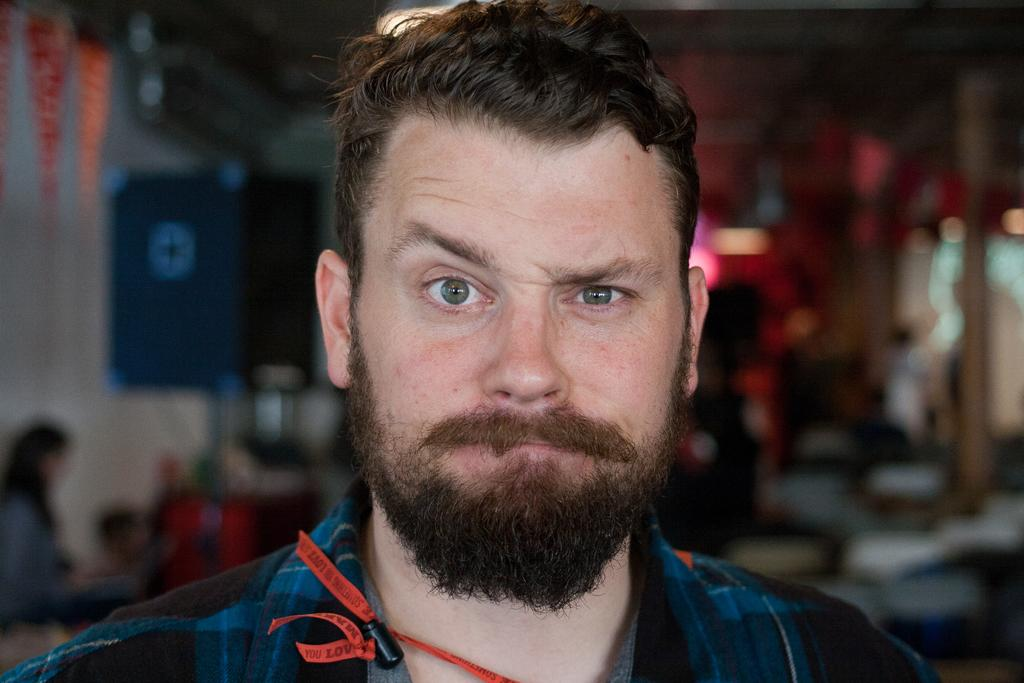Who is present in the image? There is a man in the image. What is the man wearing? The man is wearing clothes. Can you describe the person behind the man? There is a person visible behind the man. How would you describe the background of the image? The background is blurred. What type of coat is the celery wearing in the image? There is no celery present in the image, and therefore no coat can be attributed to it. 